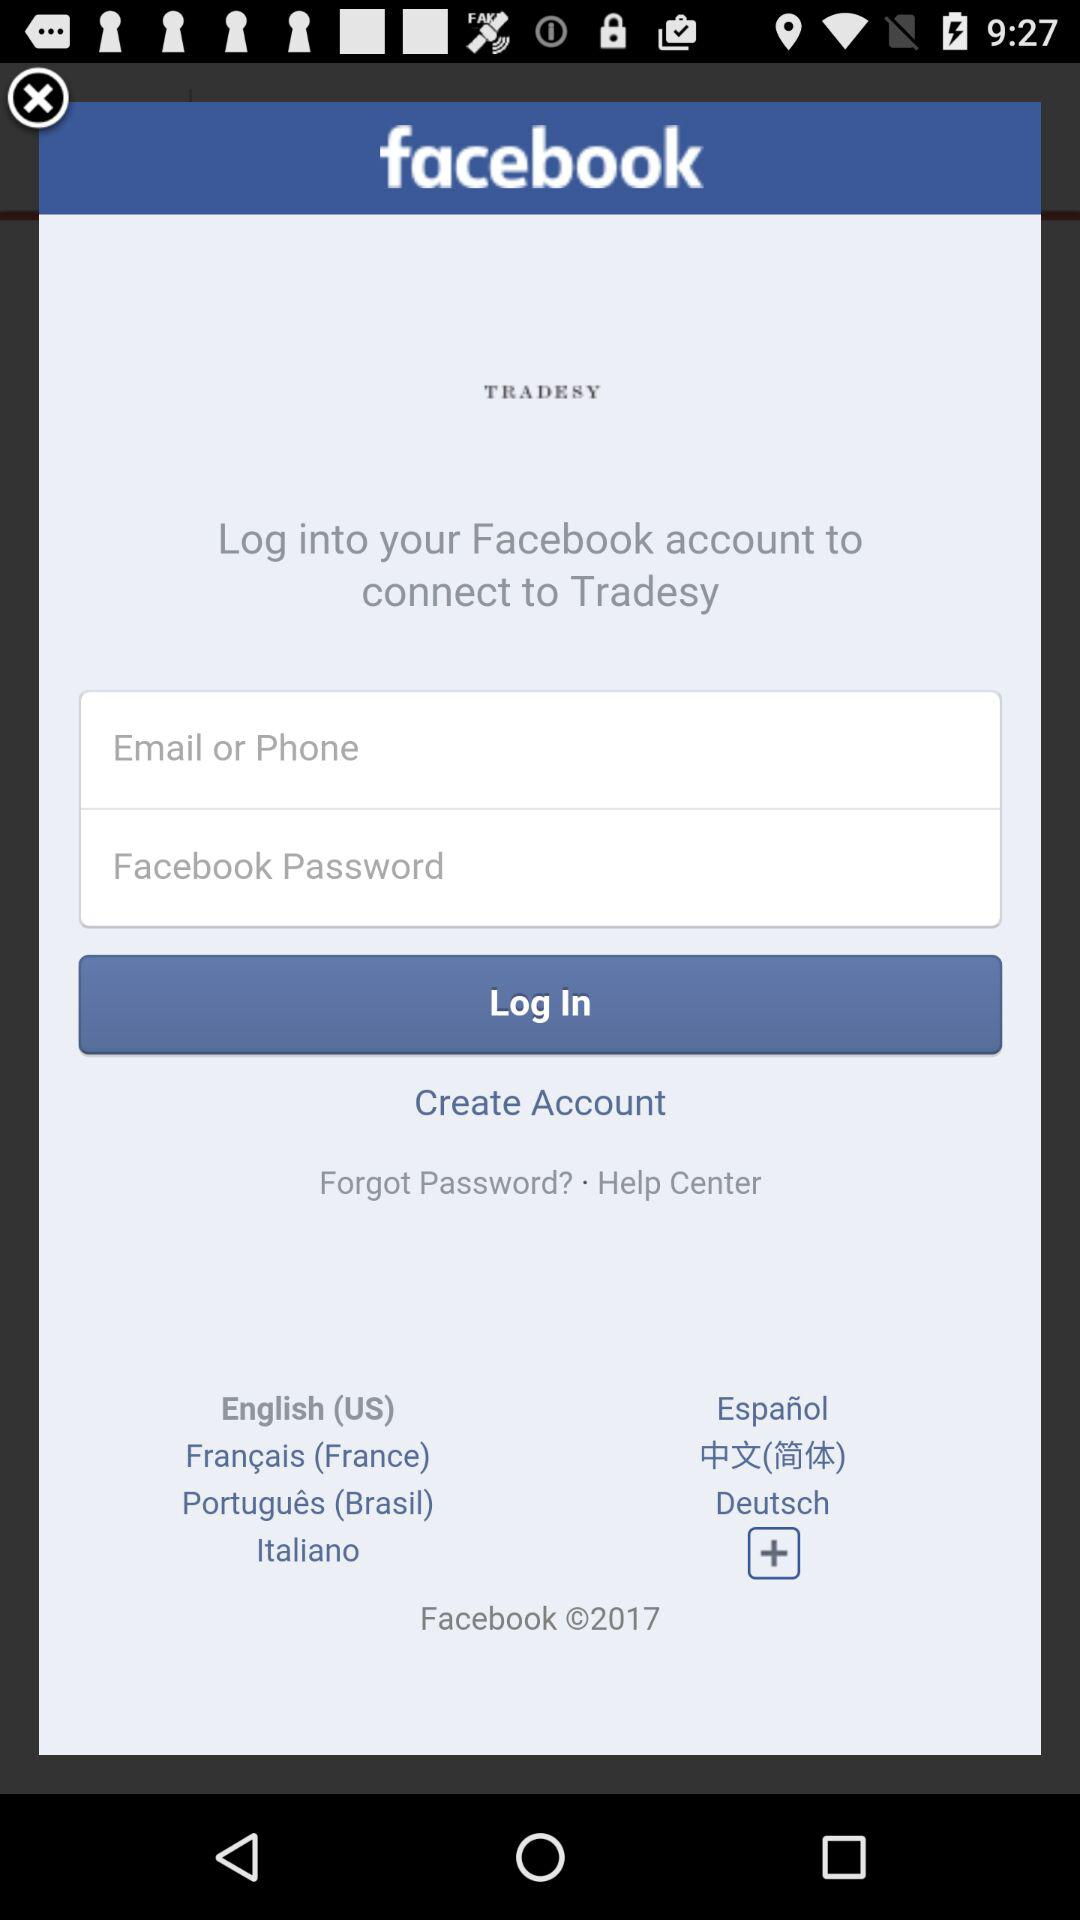What is the copyright year? The copyright year is 2017. 